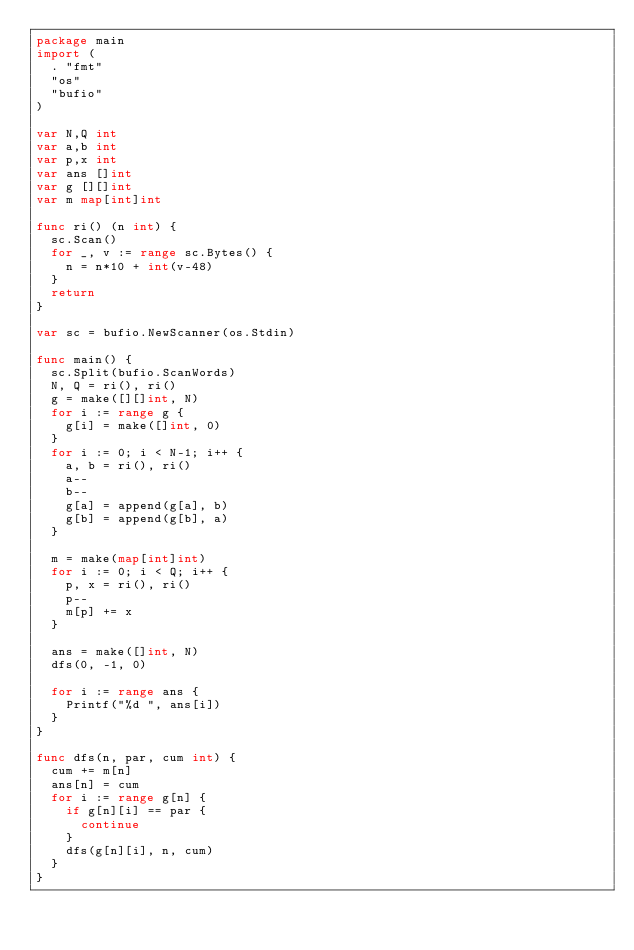Convert code to text. <code><loc_0><loc_0><loc_500><loc_500><_Go_>package main
import (
  . "fmt"
  "os"
  "bufio"
)

var N,Q int
var a,b int
var p,x int
var ans []int
var g [][]int
var m map[int]int

func ri() (n int) {
	sc.Scan()
	for _, v := range sc.Bytes() {
		n = n*10 + int(v-48)
	}
	return
}
 
var sc = bufio.NewScanner(os.Stdin)
 
func main() {
  sc.Split(bufio.ScanWords)
  N, Q = ri(), ri()
  g = make([][]int, N)
  for i := range g {
    g[i] = make([]int, 0)
  }
  for i := 0; i < N-1; i++ {
    a, b = ri(), ri()
    a--
    b--
    g[a] = append(g[a], b)
    g[b] = append(g[b], a)
  }
  
  m = make(map[int]int)
  for i := 0; i < Q; i++ {
    p, x = ri(), ri()
    p--
    m[p] += x
  }
  
  ans = make([]int, N)
  dfs(0, -1, 0)  
  
  for i := range ans {
    Printf("%d ", ans[i])
  }
}

func dfs(n, par, cum int) {
  cum += m[n]
  ans[n] = cum
  for i := range g[n] {
    if g[n][i] == par {
      continue
    }
    dfs(g[n][i], n, cum)
  }
}



</code> 